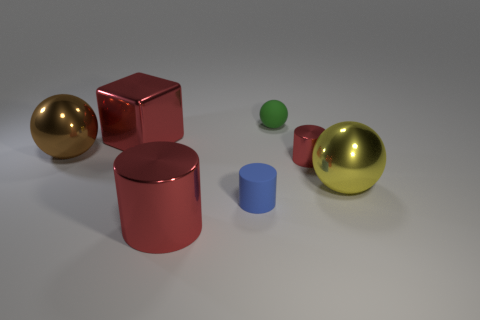Is the color of the big metallic cube the same as the small metallic object?
Ensure brevity in your answer.  Yes. What is the shape of the matte object that is in front of the large object that is on the right side of the matte thing behind the large metal block?
Provide a succinct answer. Cylinder. Is the number of cylinders left of the small metallic object greater than the number of large red cubes?
Keep it short and to the point. Yes. There is a small rubber object in front of the tiny red cylinder; is it the same shape as the large yellow thing?
Your answer should be very brief. No. What is the material of the sphere that is to the right of the small green thing?
Your response must be concise. Metal. What number of large green things have the same shape as the yellow metal object?
Give a very brief answer. 0. The small thing that is in front of the metallic sphere right of the big cylinder is made of what material?
Your answer should be compact. Rubber. What is the shape of the large thing that is the same color as the large metal cylinder?
Keep it short and to the point. Cube. Are there any small green objects made of the same material as the yellow object?
Your response must be concise. No. What shape is the tiny blue thing?
Ensure brevity in your answer.  Cylinder. 